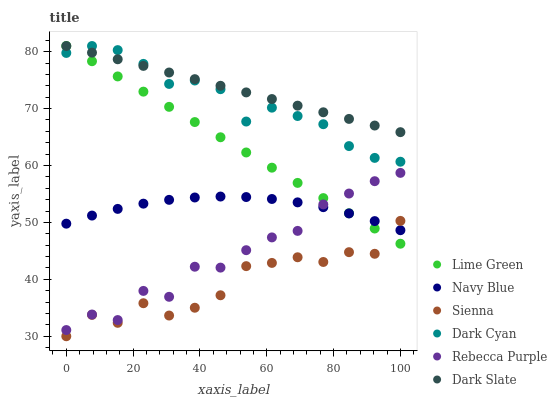Does Sienna have the minimum area under the curve?
Answer yes or no. Yes. Does Dark Slate have the maximum area under the curve?
Answer yes or no. Yes. Does Dark Slate have the minimum area under the curve?
Answer yes or no. No. Does Sienna have the maximum area under the curve?
Answer yes or no. No. Is Lime Green the smoothest?
Answer yes or no. Yes. Is Sienna the roughest?
Answer yes or no. Yes. Is Dark Slate the smoothest?
Answer yes or no. No. Is Dark Slate the roughest?
Answer yes or no. No. Does Sienna have the lowest value?
Answer yes or no. Yes. Does Dark Slate have the lowest value?
Answer yes or no. No. Does Lime Green have the highest value?
Answer yes or no. Yes. Does Sienna have the highest value?
Answer yes or no. No. Is Navy Blue less than Dark Cyan?
Answer yes or no. Yes. Is Rebecca Purple greater than Sienna?
Answer yes or no. Yes. Does Dark Slate intersect Dark Cyan?
Answer yes or no. Yes. Is Dark Slate less than Dark Cyan?
Answer yes or no. No. Is Dark Slate greater than Dark Cyan?
Answer yes or no. No. Does Navy Blue intersect Dark Cyan?
Answer yes or no. No. 